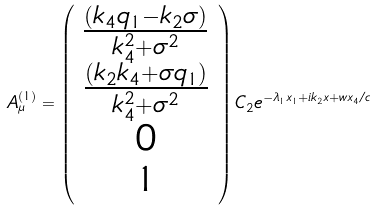<formula> <loc_0><loc_0><loc_500><loc_500>A _ { \mu } ^ { ( 1 ) } = \left ( \begin{array} { c } \frac { ( k _ { 4 } q _ { 1 } - k _ { 2 } \sigma ) } { k _ { 4 } ^ { 2 } + \sigma ^ { 2 } } \\ \frac { ( k _ { 2 } k _ { 4 } + \sigma q _ { 1 } ) } { k _ { 4 } ^ { 2 } + \sigma ^ { 2 } } \\ 0 \\ 1 \end{array} \right ) C _ { 2 } e ^ { - \lambda _ { 1 } x _ { 1 } + i k _ { 2 } x + w x _ { 4 } / c }</formula> 